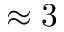<formula> <loc_0><loc_0><loc_500><loc_500>\approx 3</formula> 